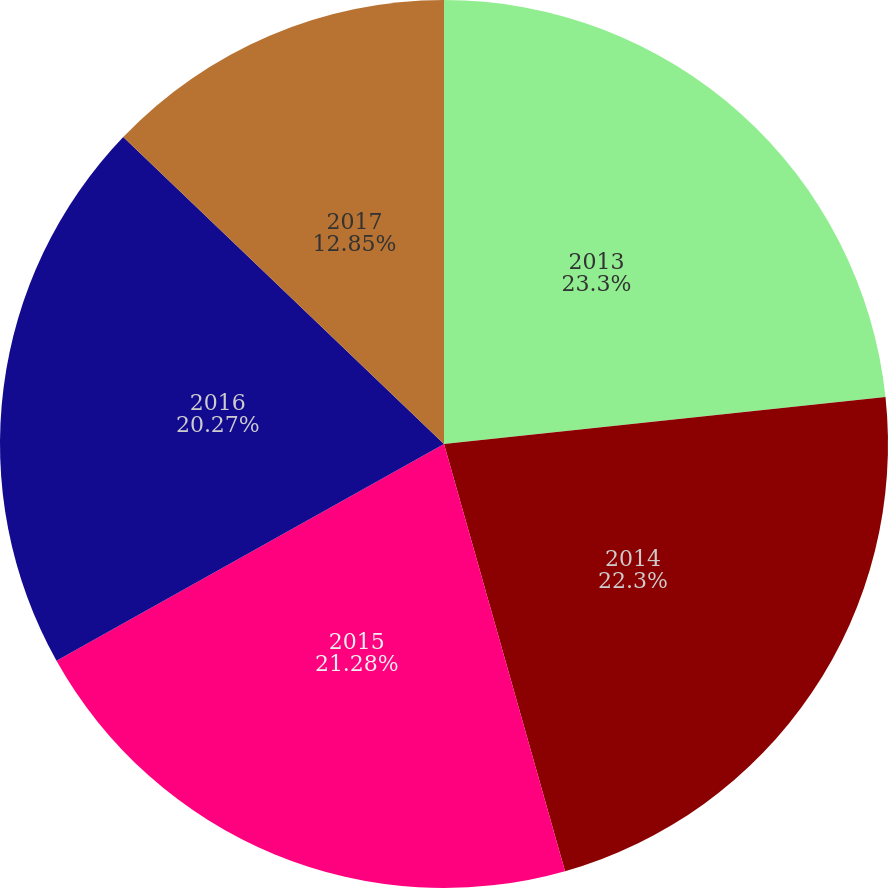<chart> <loc_0><loc_0><loc_500><loc_500><pie_chart><fcel>2013<fcel>2014<fcel>2015<fcel>2016<fcel>2017<nl><fcel>23.31%<fcel>22.3%<fcel>21.28%<fcel>20.27%<fcel>12.85%<nl></chart> 